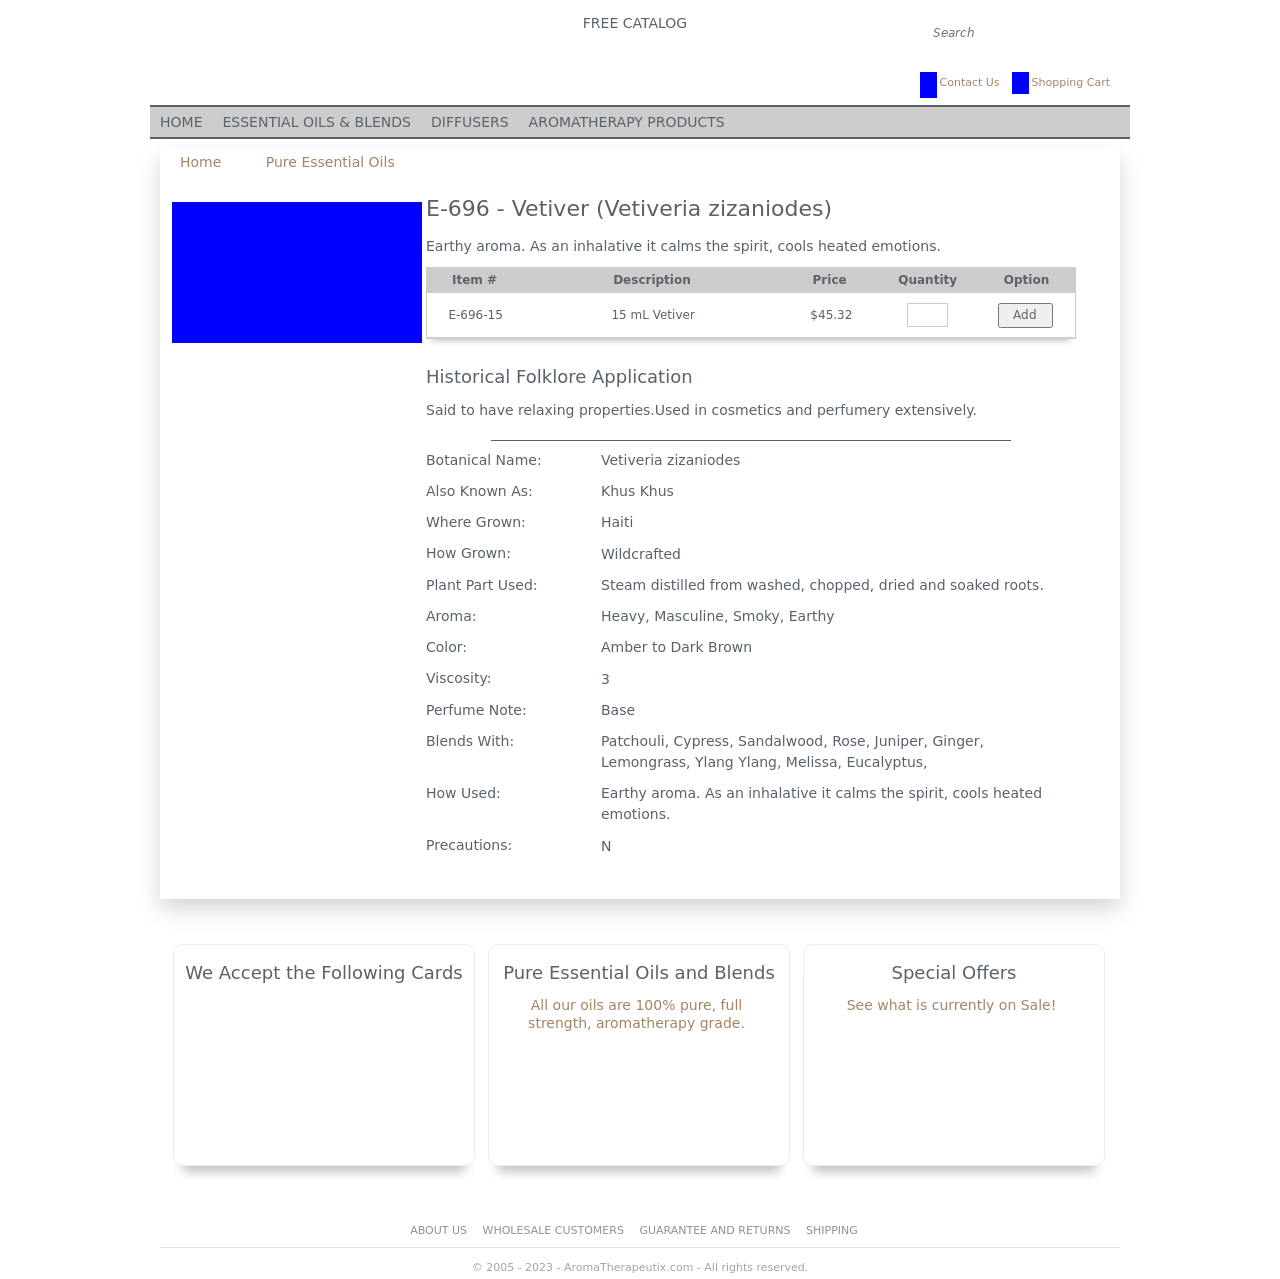How can I start building this website with HTML from the ground up? To start building a website with HTML from scratch, begin by structuring your basic HTML document with a doctype declaration, html, head, and body tags. Inside the head, include meta tags for character set and responsiveness, and a title tag. Within the body, create the main sections using div tags and use header, footer, and content tags as needed. Add links to CSS files within the head section for styling, and JavaScript files before the closing body tag for behavior. Here’s a sample template:

<!DOCTYPE html>
<html>
<head>
    <title>Your Website Title</title>
    <meta charset="UTF-8">
    <meta name="viewport" content="width=device-width, initial-scale=1.0">
    <link rel="stylesheet" type="text/css" href="styles.css">
</head>
<body>
    <header>
        <h1>Welcome to My Website</h1>
    </header>
    <nav>
        <ul>
            <li><a href="#">Home</a></li>
            <li><a href="#">About</a></li>
            <li><a href="#">Services</a></li>
        </ul>
    </nav>
    <section>
        <h2>About Us</h2>
        <p>This section contains information about the website.</p>
    </section>
    <footer>
        <p>Copyright © Your Website 2023</p>
    </footer>
</body>
</html>

This template provides a foundation to build upon, adding more sections and content as needed. 